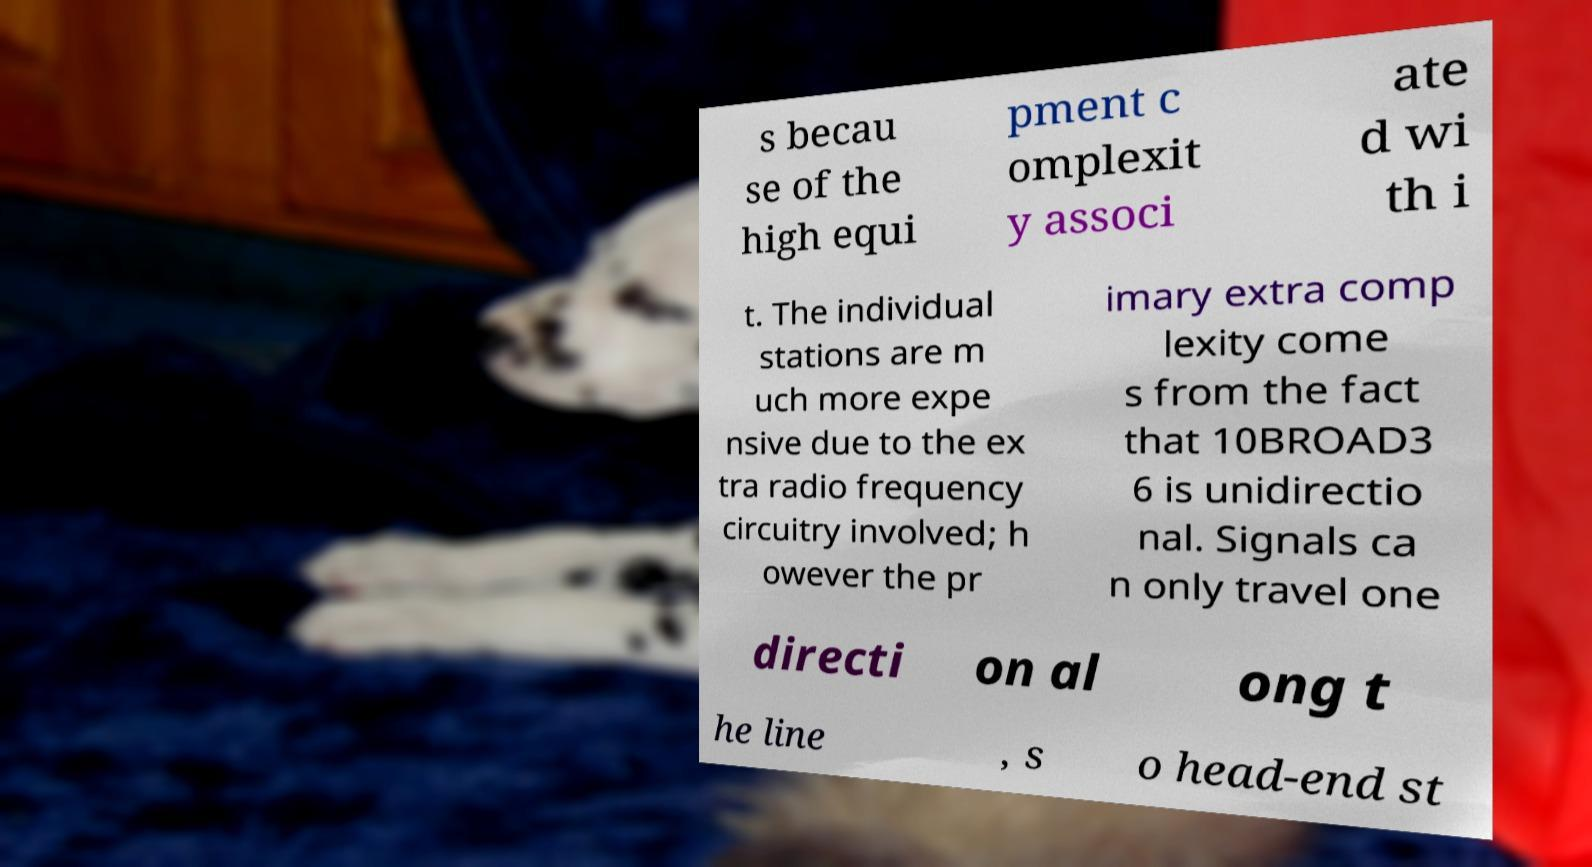For documentation purposes, I need the text within this image transcribed. Could you provide that? s becau se of the high equi pment c omplexit y associ ate d wi th i t. The individual stations are m uch more expe nsive due to the ex tra radio frequency circuitry involved; h owever the pr imary extra comp lexity come s from the fact that 10BROAD3 6 is unidirectio nal. Signals ca n only travel one directi on al ong t he line , s o head-end st 